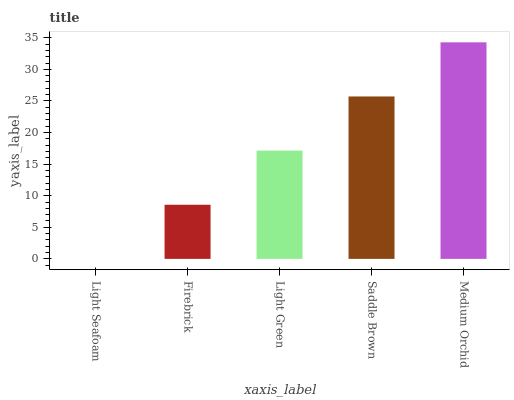Is Light Seafoam the minimum?
Answer yes or no. Yes. Is Medium Orchid the maximum?
Answer yes or no. Yes. Is Firebrick the minimum?
Answer yes or no. No. Is Firebrick the maximum?
Answer yes or no. No. Is Firebrick greater than Light Seafoam?
Answer yes or no. Yes. Is Light Seafoam less than Firebrick?
Answer yes or no. Yes. Is Light Seafoam greater than Firebrick?
Answer yes or no. No. Is Firebrick less than Light Seafoam?
Answer yes or no. No. Is Light Green the high median?
Answer yes or no. Yes. Is Light Green the low median?
Answer yes or no. Yes. Is Saddle Brown the high median?
Answer yes or no. No. Is Medium Orchid the low median?
Answer yes or no. No. 